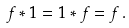<formula> <loc_0><loc_0><loc_500><loc_500>f * 1 = 1 * f = f \, .</formula> 